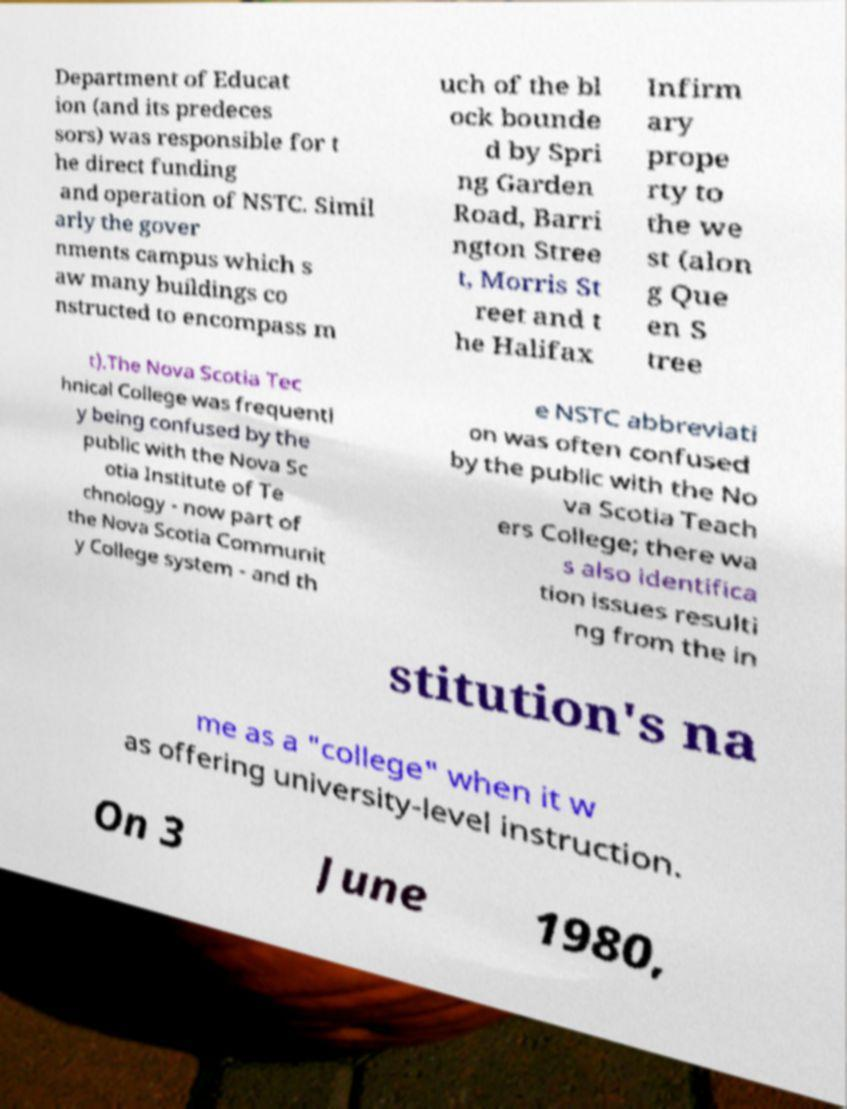Can you read and provide the text displayed in the image?This photo seems to have some interesting text. Can you extract and type it out for me? Department of Educat ion (and its predeces sors) was responsible for t he direct funding and operation of NSTC. Simil arly the gover nments campus which s aw many buildings co nstructed to encompass m uch of the bl ock bounde d by Spri ng Garden Road, Barri ngton Stree t, Morris St reet and t he Halifax Infirm ary prope rty to the we st (alon g Que en S tree t).The Nova Scotia Tec hnical College was frequentl y being confused by the public with the Nova Sc otia Institute of Te chnology - now part of the Nova Scotia Communit y College system - and th e NSTC abbreviati on was often confused by the public with the No va Scotia Teach ers College; there wa s also identifica tion issues resulti ng from the in stitution's na me as a "college" when it w as offering university-level instruction. On 3 June 1980, 